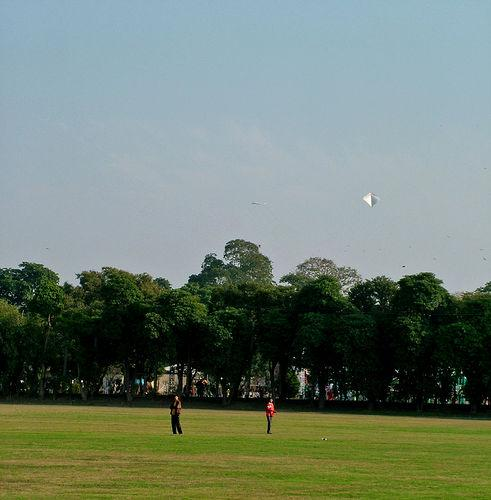What is the best shape for a kite? diamond 